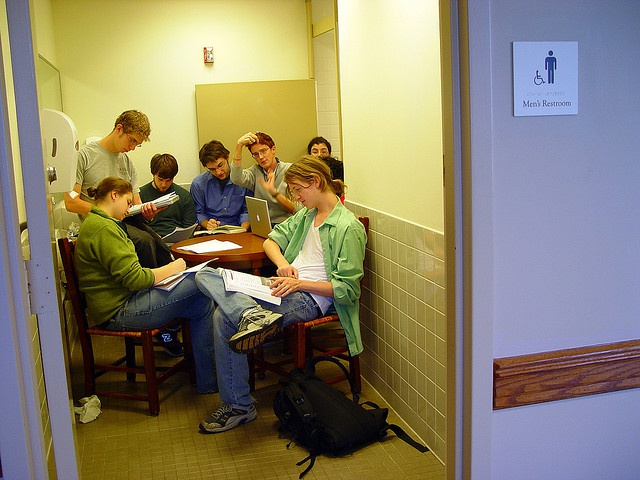Describe the objects in this image and their specific colors. I can see people in tan, black, olive, navy, and beige tones, people in tan, black, olive, and gray tones, backpack in tan, black, olive, and maroon tones, chair in tan, black, maroon, olive, and lightgray tones, and chair in tan, black, maroon, olive, and brown tones in this image. 